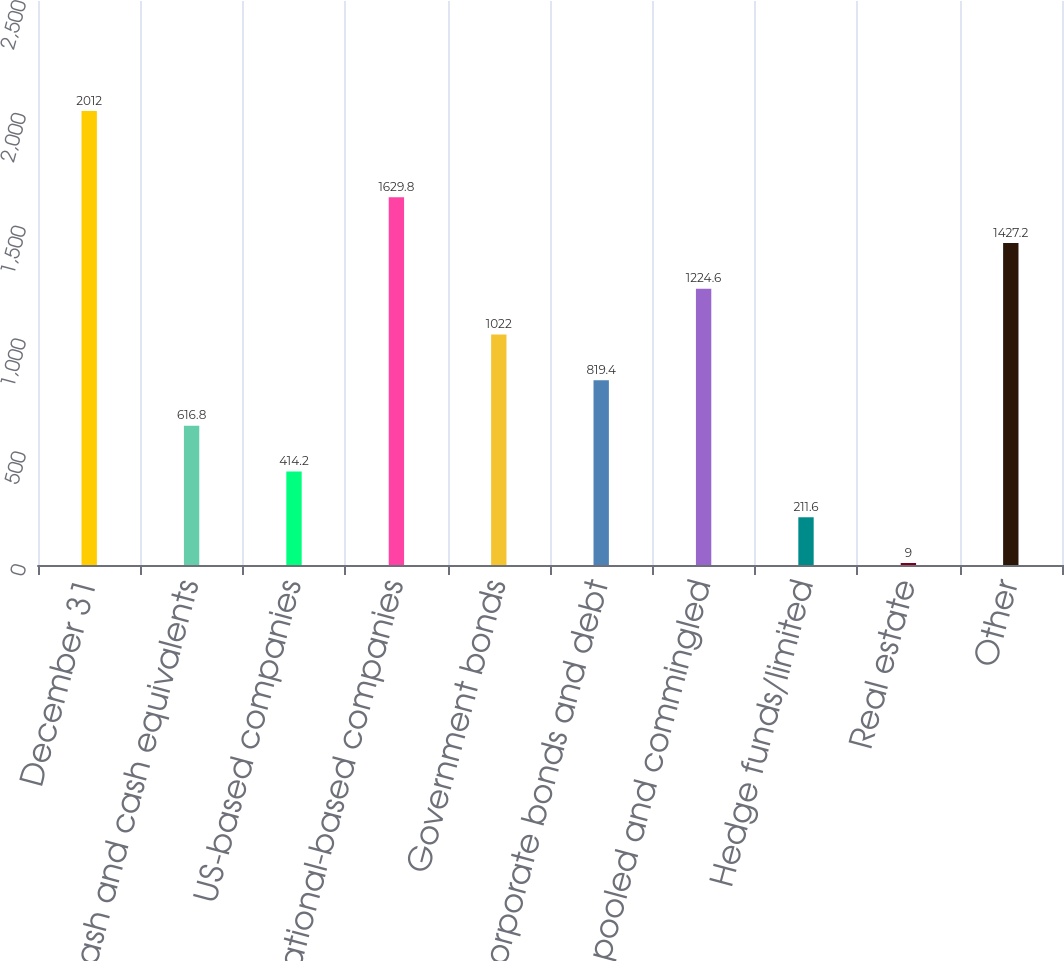Convert chart to OTSL. <chart><loc_0><loc_0><loc_500><loc_500><bar_chart><fcel>December 31<fcel>Cash and cash equivalents<fcel>US-based companies<fcel>International-based companies<fcel>Government bonds<fcel>Corporate bonds and debt<fcel>Mutual pooled and commingled<fcel>Hedge funds/limited<fcel>Real estate<fcel>Other<nl><fcel>2012<fcel>616.8<fcel>414.2<fcel>1629.8<fcel>1022<fcel>819.4<fcel>1224.6<fcel>211.6<fcel>9<fcel>1427.2<nl></chart> 